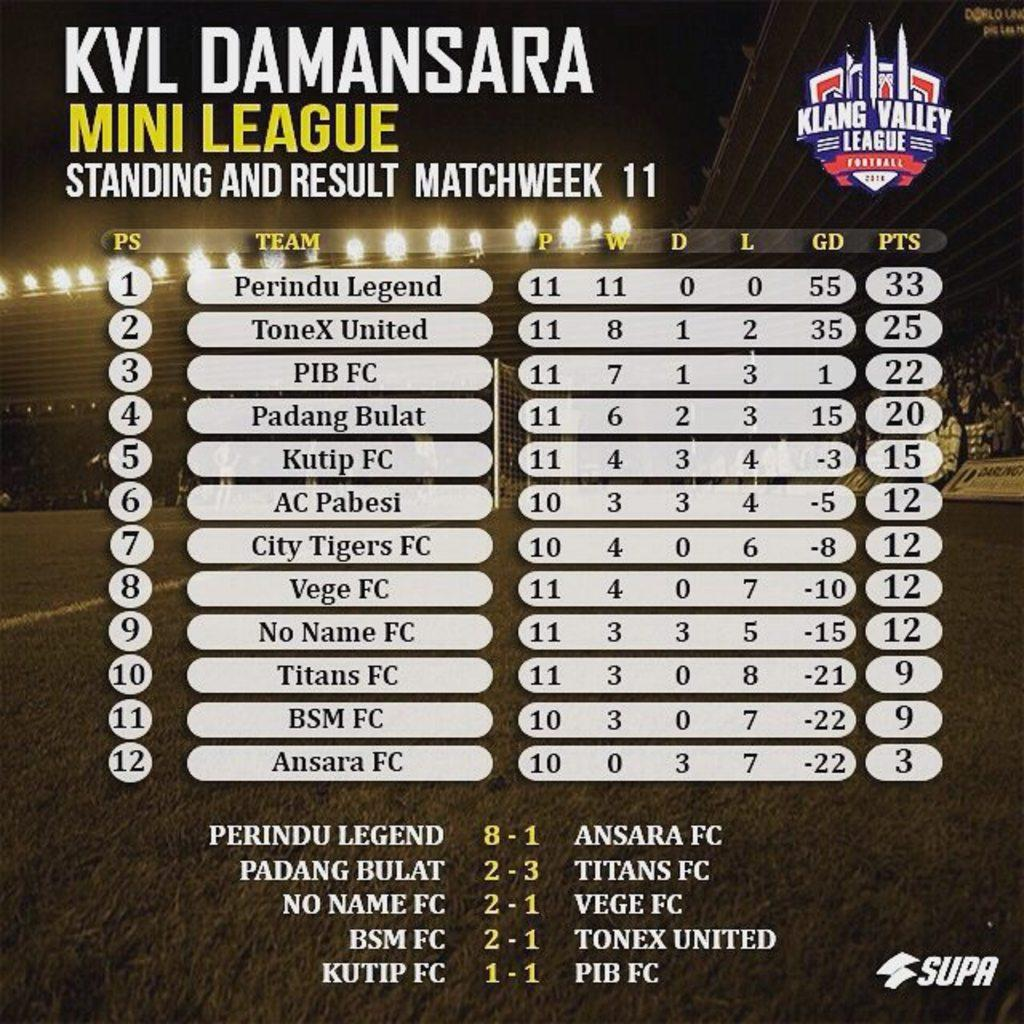Provide a one-sentence caption for the provided image. Klaang valley mini leauge standing and result matchweek 11 . 